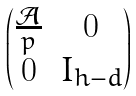<formula> <loc_0><loc_0><loc_500><loc_500>\begin{pmatrix} \frac { \mathcal { A } } p & 0 \\ 0 & I _ { h - d } \end{pmatrix}</formula> 